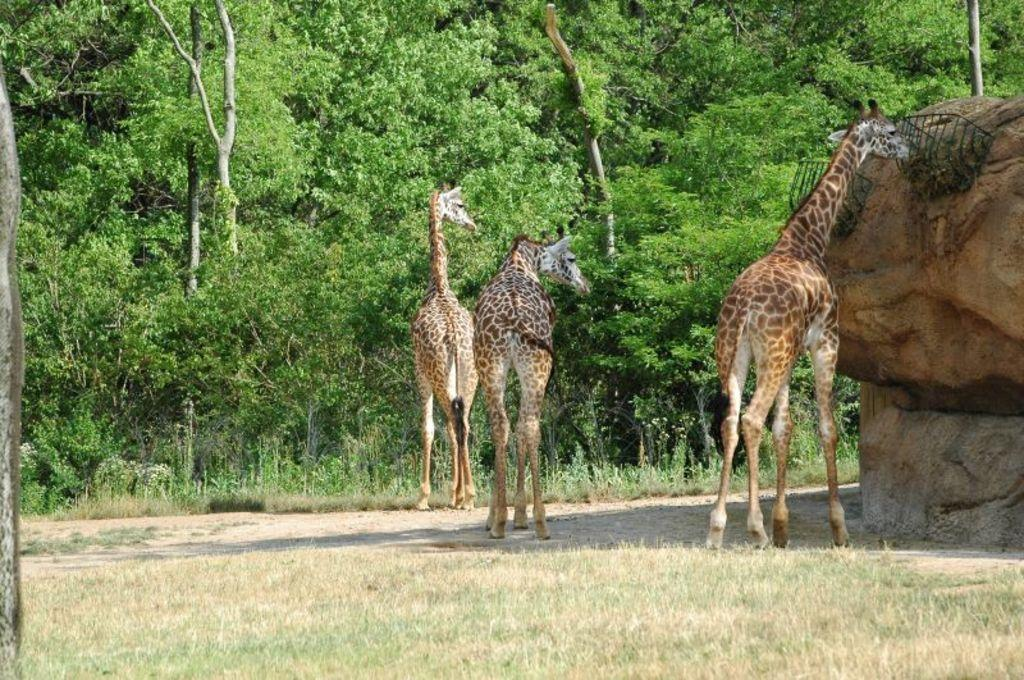What animals can be seen on the ground in the image? There are giraffes on the ground in the image. What type of vegetation is visible in the image? There is grass visible in the image, as well as plants and a group of trees. What material are the grills made of in the image? The metal grills in the image are made of metal. What part of a tree is visible in the image? The bark of a tree is visible in the image. What type of soup is being served in the image? There is no soup present in the image; it features giraffes, grass, metal grills, tree bark, plants, and a group of trees. 